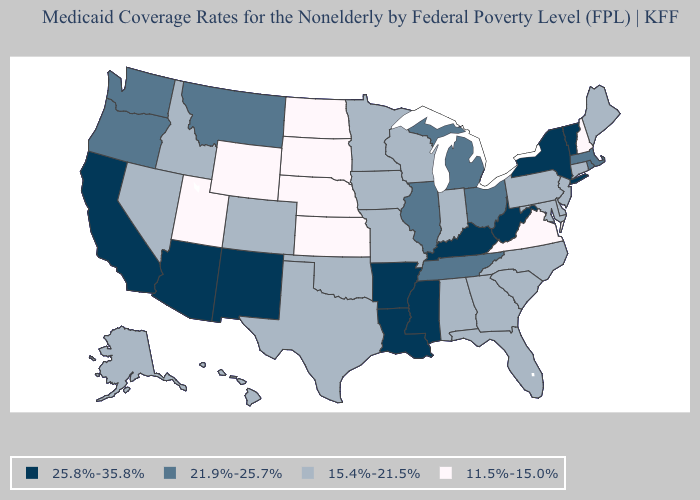What is the value of Georgia?
Write a very short answer. 15.4%-21.5%. Which states have the lowest value in the South?
Be succinct. Virginia. What is the highest value in the USA?
Quick response, please. 25.8%-35.8%. What is the value of Arizona?
Be succinct. 25.8%-35.8%. Is the legend a continuous bar?
Answer briefly. No. Does Missouri have a higher value than Delaware?
Answer briefly. No. Among the states that border Rhode Island , does Massachusetts have the highest value?
Short answer required. Yes. Does Kentucky have the same value as Mississippi?
Short answer required. Yes. How many symbols are there in the legend?
Be succinct. 4. What is the value of New Mexico?
Short answer required. 25.8%-35.8%. Which states have the highest value in the USA?
Give a very brief answer. Arizona, Arkansas, California, Kentucky, Louisiana, Mississippi, New Mexico, New York, Vermont, West Virginia. What is the value of South Dakota?
Quick response, please. 11.5%-15.0%. What is the lowest value in states that border Mississippi?
Give a very brief answer. 15.4%-21.5%. Does the first symbol in the legend represent the smallest category?
Keep it brief. No. Name the states that have a value in the range 21.9%-25.7%?
Be succinct. Illinois, Massachusetts, Michigan, Montana, Ohio, Oregon, Rhode Island, Tennessee, Washington. 